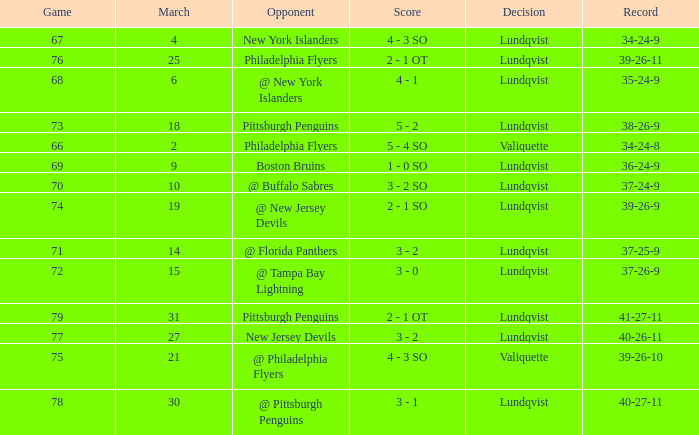Give me the full table as a dictionary. {'header': ['Game', 'March', 'Opponent', 'Score', 'Decision', 'Record'], 'rows': [['67', '4', 'New York Islanders', '4 - 3 SO', 'Lundqvist', '34-24-9'], ['76', '25', 'Philadelphia Flyers', '2 - 1 OT', 'Lundqvist', '39-26-11'], ['68', '6', '@ New York Islanders', '4 - 1', 'Lundqvist', '35-24-9'], ['73', '18', 'Pittsburgh Penguins', '5 - 2', 'Lundqvist', '38-26-9'], ['66', '2', 'Philadelphia Flyers', '5 - 4 SO', 'Valiquette', '34-24-8'], ['69', '9', 'Boston Bruins', '1 - 0 SO', 'Lundqvist', '36-24-9'], ['70', '10', '@ Buffalo Sabres', '3 - 2 SO', 'Lundqvist', '37-24-9'], ['74', '19', '@ New Jersey Devils', '2 - 1 SO', 'Lundqvist', '39-26-9'], ['71', '14', '@ Florida Panthers', '3 - 2', 'Lundqvist', '37-25-9'], ['72', '15', '@ Tampa Bay Lightning', '3 - 0', 'Lundqvist', '37-26-9'], ['79', '31', 'Pittsburgh Penguins', '2 - 1 OT', 'Lundqvist', '41-27-11'], ['77', '27', 'New Jersey Devils', '3 - 2', 'Lundqvist', '40-26-11'], ['75', '21', '@ Philadelphia Flyers', '4 - 3 SO', 'Valiquette', '39-26-10'], ['78', '30', '@ Pittsburgh Penguins', '3 - 1', 'Lundqvist', '40-27-11']]} In a game against the new york islanders, which match had a score of less than 69 when the march was greater than 2? 4 - 3 SO. 